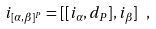Convert formula to latex. <formula><loc_0><loc_0><loc_500><loc_500>i _ { [ \alpha , \beta ] ^ { P } } = [ [ i _ { \alpha } , d _ { P } ] , i _ { \beta } ] \ ,</formula> 